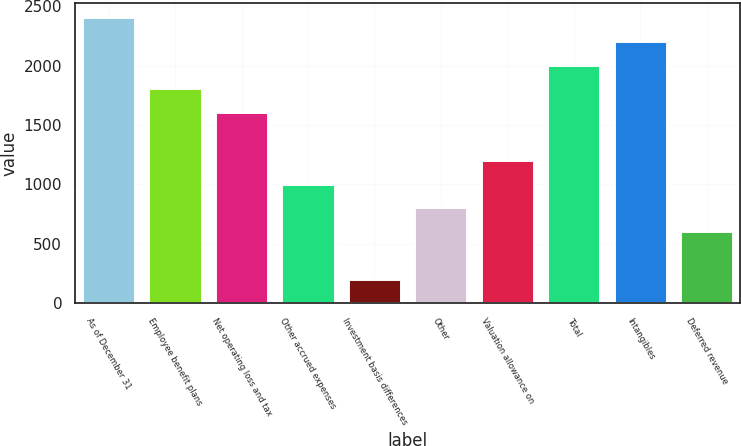<chart> <loc_0><loc_0><loc_500><loc_500><bar_chart><fcel>As of December 31<fcel>Employee benefit plans<fcel>Net operating loss and tax<fcel>Other accrued expenses<fcel>Investment basis differences<fcel>Other<fcel>Valuation allowance on<fcel>Total<fcel>Intangibles<fcel>Deferred revenue<nl><fcel>2411<fcel>1809.5<fcel>1609<fcel>1007.5<fcel>205.5<fcel>807<fcel>1208<fcel>2010<fcel>2210.5<fcel>606.5<nl></chart> 